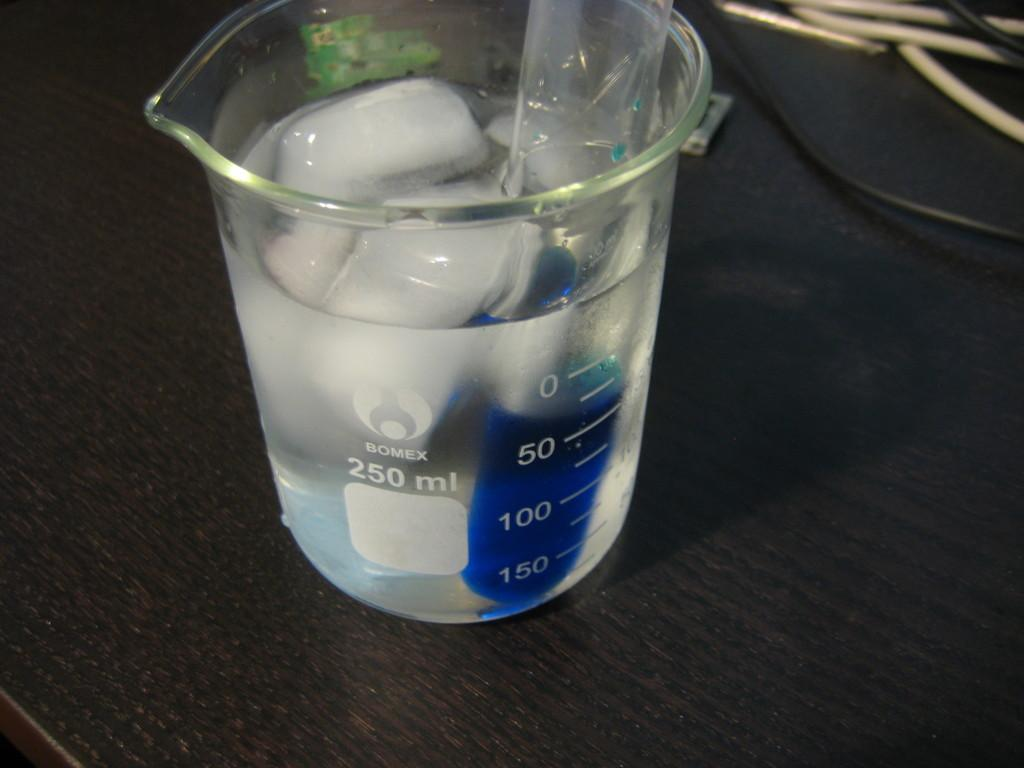<image>
Give a short and clear explanation of the subsequent image. A 250 ml beaker is filed with liquid and ice cubes. 